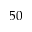Convert formula to latex. <formula><loc_0><loc_0><loc_500><loc_500>5 0</formula> 